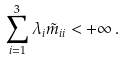<formula> <loc_0><loc_0><loc_500><loc_500>\sum _ { i = 1 } ^ { 3 } \lambda _ { i } \tilde { m } _ { i i } < + \infty \, .</formula> 